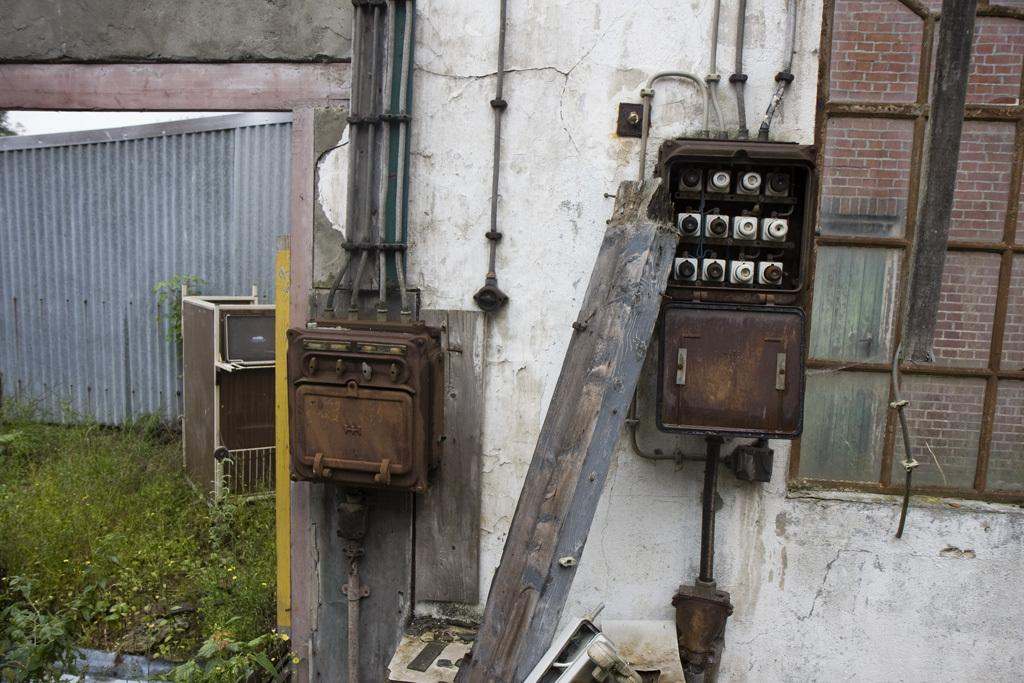What type of vegetation can be seen in the image? There is grass in the image. What type of structure is visible in the image? There is a wall in the image. What type of equipment can be seen in the image? There are pipes in the image. What architectural feature is present in the image? There is a window in the image. What type of device is visible in the image? There is a meter in the image. Can you describe the time of day when the image was taken? The image was taken during the day. What type of reason does the manager provide for planting the seed in the image? There is no manager or seed present in the image. What type of seed is used to grow the grass in the image? There is no seed visible in the image, only grass. 